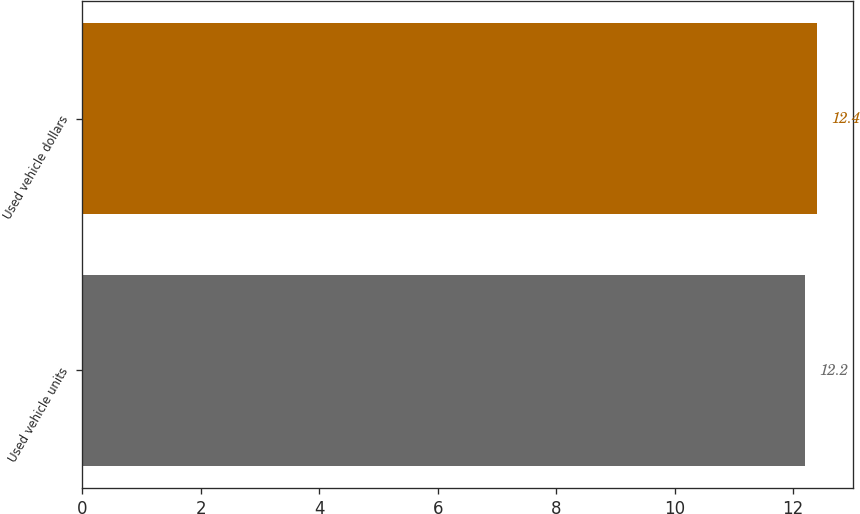Convert chart. <chart><loc_0><loc_0><loc_500><loc_500><bar_chart><fcel>Used vehicle units<fcel>Used vehicle dollars<nl><fcel>12.2<fcel>12.4<nl></chart> 